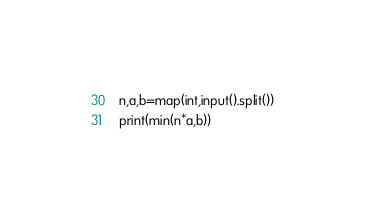<code> <loc_0><loc_0><loc_500><loc_500><_Python_>n,a,b=map(int,input().split())
print(min(n*a,b))</code> 